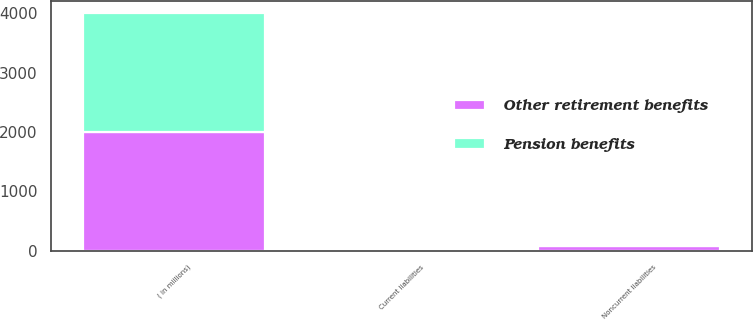<chart> <loc_0><loc_0><loc_500><loc_500><stacked_bar_chart><ecel><fcel>( in millions)<fcel>Current liabilities<fcel>Noncurrent liabilities<nl><fcel>Other retirement benefits<fcel>2008<fcel>0.9<fcel>72.1<nl><fcel>Pension benefits<fcel>2008<fcel>1.1<fcel>13.9<nl></chart> 